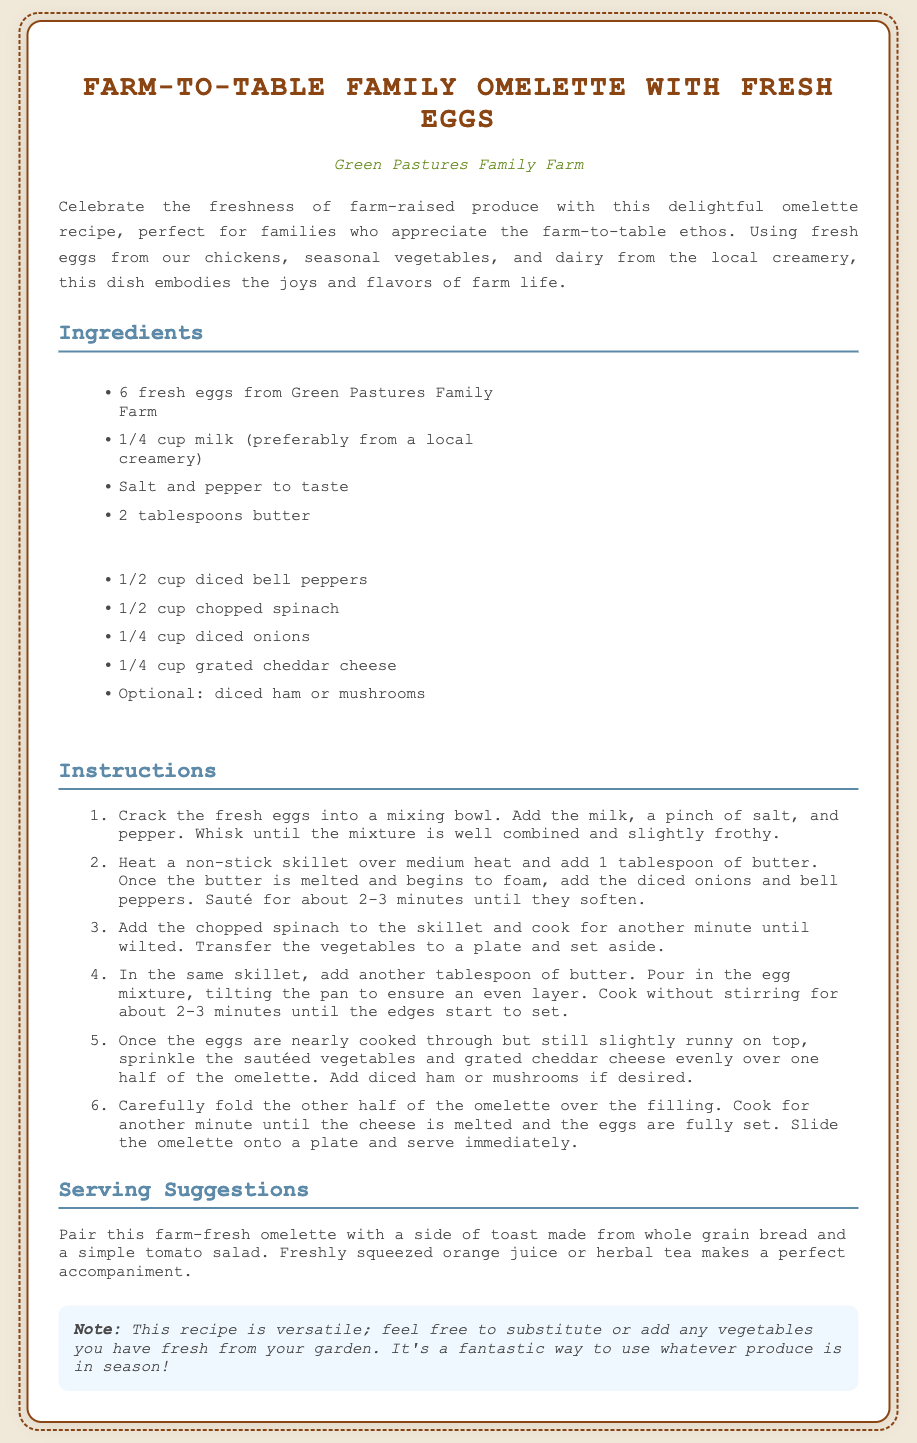What is the title of the recipe? The title of the recipe is found at the top of the document.
Answer: Farm-to-Table Family Omelette with Fresh Eggs Who is the farm associated with the recipe? The name of the farm is mentioned under the title.
Answer: Green Pastures Family Farm How many eggs are needed for the omelette? The number of eggs required is listed in the ingredients section.
Answer: 6 fresh eggs What is the first step in the instructions? The first step is described in the instructions section.
Answer: Crack the fresh eggs into a mixing bowl What optional ingredients can be included? The optional ingredients are specified in the ingredients list.
Answer: diced ham or mushrooms What is suggested to pair with the omelette? Serving suggestions are provided towards the end of the document.
Answer: side of toast made from whole grain bread What color is the background of the recipe card? The background color is specified in the style section of the document.
Answer: #f0e8d9 How long should the vegetables be sautéed? The cooking time for the vegetables is indicated in the instructions.
Answer: about 2-3 minutes 